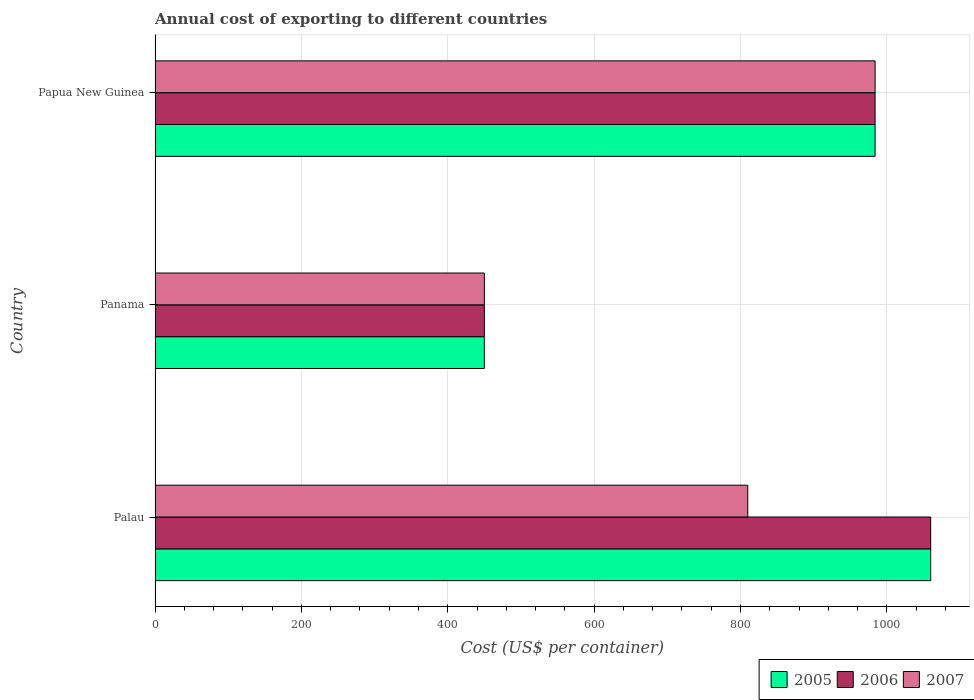Are the number of bars per tick equal to the number of legend labels?
Make the answer very short. Yes. How many bars are there on the 2nd tick from the top?
Keep it short and to the point. 3. What is the label of the 2nd group of bars from the top?
Offer a very short reply. Panama. What is the total annual cost of exporting in 2005 in Papua New Guinea?
Your answer should be compact. 984. Across all countries, what is the maximum total annual cost of exporting in 2005?
Provide a short and direct response. 1060. Across all countries, what is the minimum total annual cost of exporting in 2006?
Offer a terse response. 450. In which country was the total annual cost of exporting in 2005 maximum?
Your answer should be very brief. Palau. In which country was the total annual cost of exporting in 2007 minimum?
Offer a very short reply. Panama. What is the total total annual cost of exporting in 2005 in the graph?
Offer a terse response. 2494. What is the difference between the total annual cost of exporting in 2005 in Palau and that in Panama?
Provide a short and direct response. 610. What is the difference between the total annual cost of exporting in 2005 in Papua New Guinea and the total annual cost of exporting in 2007 in Palau?
Your answer should be compact. 174. What is the average total annual cost of exporting in 2007 per country?
Offer a very short reply. 748. What is the difference between the total annual cost of exporting in 2006 and total annual cost of exporting in 2005 in Palau?
Ensure brevity in your answer.  0. In how many countries, is the total annual cost of exporting in 2006 greater than 440 US$?
Provide a succinct answer. 3. What is the ratio of the total annual cost of exporting in 2007 in Panama to that in Papua New Guinea?
Provide a short and direct response. 0.46. Is the total annual cost of exporting in 2006 in Panama less than that in Papua New Guinea?
Your answer should be compact. Yes. Is the difference between the total annual cost of exporting in 2006 in Palau and Panama greater than the difference between the total annual cost of exporting in 2005 in Palau and Panama?
Offer a very short reply. No. What is the difference between the highest and the lowest total annual cost of exporting in 2005?
Offer a terse response. 610. What does the 1st bar from the top in Panama represents?
Offer a terse response. 2007. Is it the case that in every country, the sum of the total annual cost of exporting in 2007 and total annual cost of exporting in 2005 is greater than the total annual cost of exporting in 2006?
Your answer should be very brief. Yes. How many bars are there?
Your answer should be very brief. 9. What is the difference between two consecutive major ticks on the X-axis?
Your answer should be compact. 200. Are the values on the major ticks of X-axis written in scientific E-notation?
Provide a succinct answer. No. Does the graph contain grids?
Offer a very short reply. Yes. What is the title of the graph?
Your response must be concise. Annual cost of exporting to different countries. Does "2008" appear as one of the legend labels in the graph?
Keep it short and to the point. No. What is the label or title of the X-axis?
Provide a short and direct response. Cost (US$ per container). What is the Cost (US$ per container) in 2005 in Palau?
Give a very brief answer. 1060. What is the Cost (US$ per container) in 2006 in Palau?
Offer a very short reply. 1060. What is the Cost (US$ per container) in 2007 in Palau?
Give a very brief answer. 810. What is the Cost (US$ per container) in 2005 in Panama?
Provide a succinct answer. 450. What is the Cost (US$ per container) of 2006 in Panama?
Offer a terse response. 450. What is the Cost (US$ per container) of 2007 in Panama?
Make the answer very short. 450. What is the Cost (US$ per container) in 2005 in Papua New Guinea?
Offer a terse response. 984. What is the Cost (US$ per container) of 2006 in Papua New Guinea?
Give a very brief answer. 984. What is the Cost (US$ per container) in 2007 in Papua New Guinea?
Provide a succinct answer. 984. Across all countries, what is the maximum Cost (US$ per container) in 2005?
Give a very brief answer. 1060. Across all countries, what is the maximum Cost (US$ per container) of 2006?
Provide a succinct answer. 1060. Across all countries, what is the maximum Cost (US$ per container) of 2007?
Your answer should be compact. 984. Across all countries, what is the minimum Cost (US$ per container) of 2005?
Provide a succinct answer. 450. Across all countries, what is the minimum Cost (US$ per container) in 2006?
Give a very brief answer. 450. Across all countries, what is the minimum Cost (US$ per container) in 2007?
Provide a succinct answer. 450. What is the total Cost (US$ per container) of 2005 in the graph?
Your answer should be compact. 2494. What is the total Cost (US$ per container) in 2006 in the graph?
Ensure brevity in your answer.  2494. What is the total Cost (US$ per container) of 2007 in the graph?
Your answer should be compact. 2244. What is the difference between the Cost (US$ per container) in 2005 in Palau and that in Panama?
Your response must be concise. 610. What is the difference between the Cost (US$ per container) of 2006 in Palau and that in Panama?
Your answer should be very brief. 610. What is the difference between the Cost (US$ per container) of 2007 in Palau and that in Panama?
Offer a very short reply. 360. What is the difference between the Cost (US$ per container) of 2006 in Palau and that in Papua New Guinea?
Provide a succinct answer. 76. What is the difference between the Cost (US$ per container) of 2007 in Palau and that in Papua New Guinea?
Provide a succinct answer. -174. What is the difference between the Cost (US$ per container) in 2005 in Panama and that in Papua New Guinea?
Keep it short and to the point. -534. What is the difference between the Cost (US$ per container) of 2006 in Panama and that in Papua New Guinea?
Your response must be concise. -534. What is the difference between the Cost (US$ per container) of 2007 in Panama and that in Papua New Guinea?
Provide a succinct answer. -534. What is the difference between the Cost (US$ per container) of 2005 in Palau and the Cost (US$ per container) of 2006 in Panama?
Provide a succinct answer. 610. What is the difference between the Cost (US$ per container) of 2005 in Palau and the Cost (US$ per container) of 2007 in Panama?
Keep it short and to the point. 610. What is the difference between the Cost (US$ per container) of 2006 in Palau and the Cost (US$ per container) of 2007 in Panama?
Offer a terse response. 610. What is the difference between the Cost (US$ per container) in 2006 in Palau and the Cost (US$ per container) in 2007 in Papua New Guinea?
Your answer should be compact. 76. What is the difference between the Cost (US$ per container) in 2005 in Panama and the Cost (US$ per container) in 2006 in Papua New Guinea?
Provide a short and direct response. -534. What is the difference between the Cost (US$ per container) in 2005 in Panama and the Cost (US$ per container) in 2007 in Papua New Guinea?
Provide a succinct answer. -534. What is the difference between the Cost (US$ per container) of 2006 in Panama and the Cost (US$ per container) of 2007 in Papua New Guinea?
Your response must be concise. -534. What is the average Cost (US$ per container) of 2005 per country?
Give a very brief answer. 831.33. What is the average Cost (US$ per container) in 2006 per country?
Make the answer very short. 831.33. What is the average Cost (US$ per container) in 2007 per country?
Your response must be concise. 748. What is the difference between the Cost (US$ per container) of 2005 and Cost (US$ per container) of 2006 in Palau?
Offer a terse response. 0. What is the difference between the Cost (US$ per container) of 2005 and Cost (US$ per container) of 2007 in Palau?
Offer a very short reply. 250. What is the difference between the Cost (US$ per container) of 2006 and Cost (US$ per container) of 2007 in Palau?
Keep it short and to the point. 250. What is the difference between the Cost (US$ per container) in 2005 and Cost (US$ per container) in 2006 in Panama?
Provide a succinct answer. 0. What is the difference between the Cost (US$ per container) of 2005 and Cost (US$ per container) of 2007 in Panama?
Offer a terse response. 0. What is the difference between the Cost (US$ per container) of 2005 and Cost (US$ per container) of 2007 in Papua New Guinea?
Offer a very short reply. 0. What is the ratio of the Cost (US$ per container) in 2005 in Palau to that in Panama?
Provide a short and direct response. 2.36. What is the ratio of the Cost (US$ per container) in 2006 in Palau to that in Panama?
Give a very brief answer. 2.36. What is the ratio of the Cost (US$ per container) in 2007 in Palau to that in Panama?
Your response must be concise. 1.8. What is the ratio of the Cost (US$ per container) of 2005 in Palau to that in Papua New Guinea?
Keep it short and to the point. 1.08. What is the ratio of the Cost (US$ per container) of 2006 in Palau to that in Papua New Guinea?
Offer a very short reply. 1.08. What is the ratio of the Cost (US$ per container) of 2007 in Palau to that in Papua New Guinea?
Ensure brevity in your answer.  0.82. What is the ratio of the Cost (US$ per container) in 2005 in Panama to that in Papua New Guinea?
Your answer should be very brief. 0.46. What is the ratio of the Cost (US$ per container) of 2006 in Panama to that in Papua New Guinea?
Keep it short and to the point. 0.46. What is the ratio of the Cost (US$ per container) of 2007 in Panama to that in Papua New Guinea?
Make the answer very short. 0.46. What is the difference between the highest and the second highest Cost (US$ per container) in 2006?
Make the answer very short. 76. What is the difference between the highest and the second highest Cost (US$ per container) in 2007?
Give a very brief answer. 174. What is the difference between the highest and the lowest Cost (US$ per container) of 2005?
Keep it short and to the point. 610. What is the difference between the highest and the lowest Cost (US$ per container) in 2006?
Provide a short and direct response. 610. What is the difference between the highest and the lowest Cost (US$ per container) of 2007?
Keep it short and to the point. 534. 